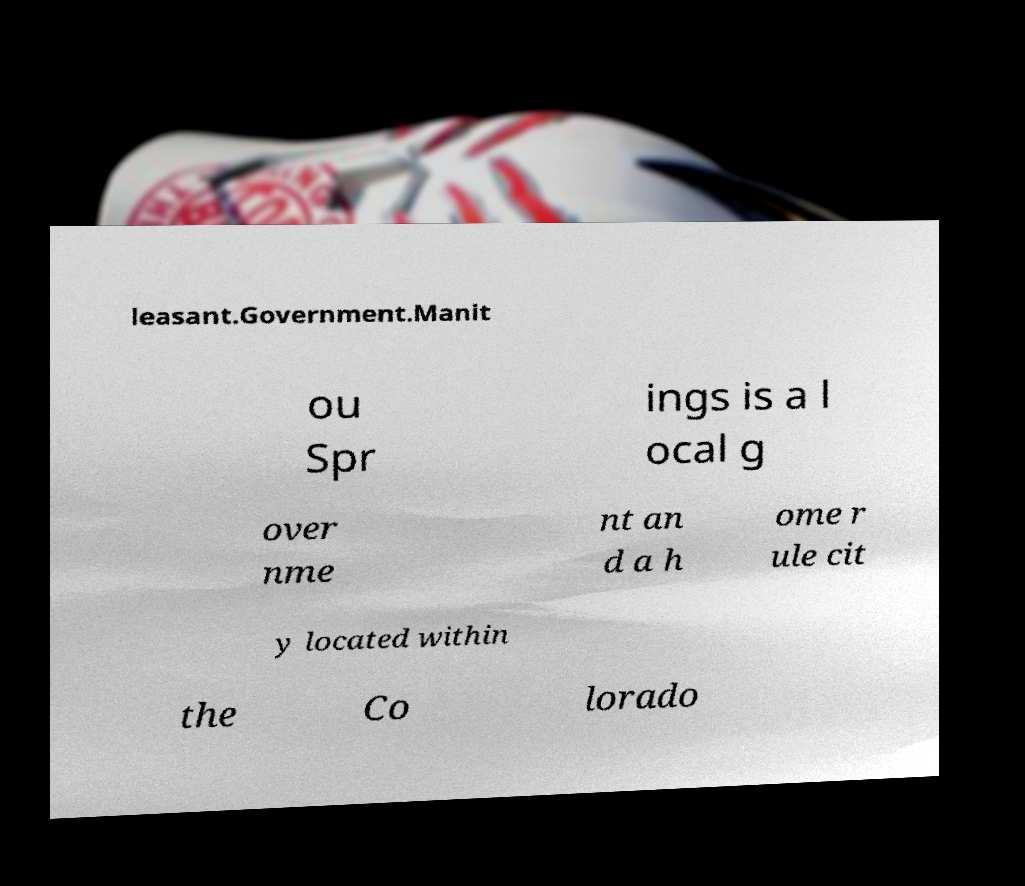There's text embedded in this image that I need extracted. Can you transcribe it verbatim? leasant.Government.Manit ou Spr ings is a l ocal g over nme nt an d a h ome r ule cit y located within the Co lorado 